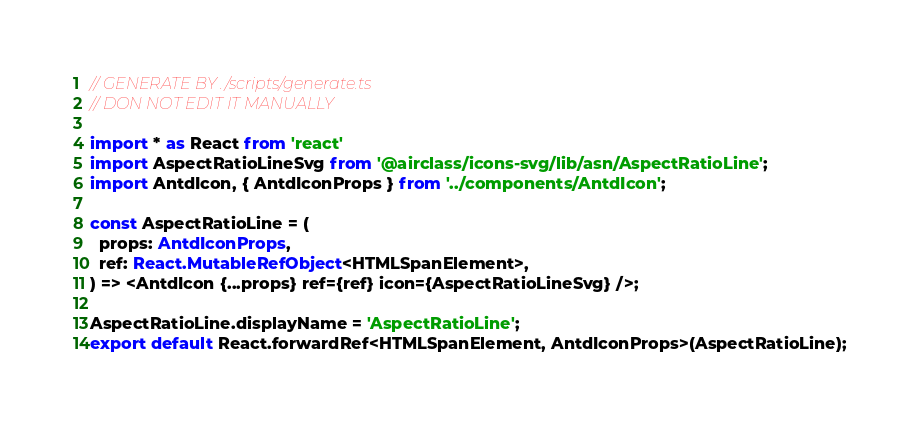<code> <loc_0><loc_0><loc_500><loc_500><_TypeScript_>// GENERATE BY ./scripts/generate.ts
// DON NOT EDIT IT MANUALLY

import * as React from 'react'
import AspectRatioLineSvg from '@airclass/icons-svg/lib/asn/AspectRatioLine';
import AntdIcon, { AntdIconProps } from '../components/AntdIcon';

const AspectRatioLine = (
  props: AntdIconProps,
  ref: React.MutableRefObject<HTMLSpanElement>,
) => <AntdIcon {...props} ref={ref} icon={AspectRatioLineSvg} />;

AspectRatioLine.displayName = 'AspectRatioLine';
export default React.forwardRef<HTMLSpanElement, AntdIconProps>(AspectRatioLine);</code> 